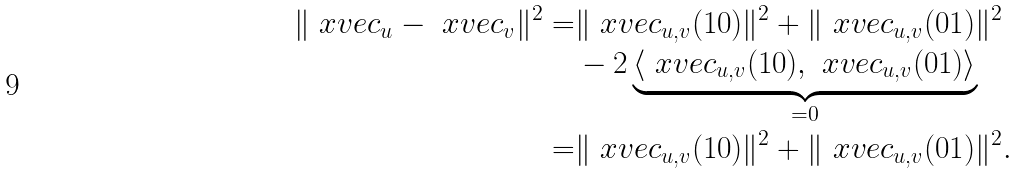<formula> <loc_0><loc_0><loc_500><loc_500>\| \ x v e c _ { u } - \ x v e c _ { v } \| ^ { 2 } = & \| \ x v e c _ { u , v } ( 1 0 ) \| ^ { 2 } + \| \ x v e c _ { u , v } ( 0 1 ) \| ^ { 2 } \\ & - 2 \underbrace { \langle \ x v e c _ { u , v } ( 1 0 ) , \ x v e c _ { u , v } ( 0 1 ) \rangle } _ { = 0 } \\ = & \| \ x v e c _ { u , v } ( 1 0 ) \| ^ { 2 } + \| \ x v e c _ { u , v } ( 0 1 ) \| ^ { 2 } .</formula> 